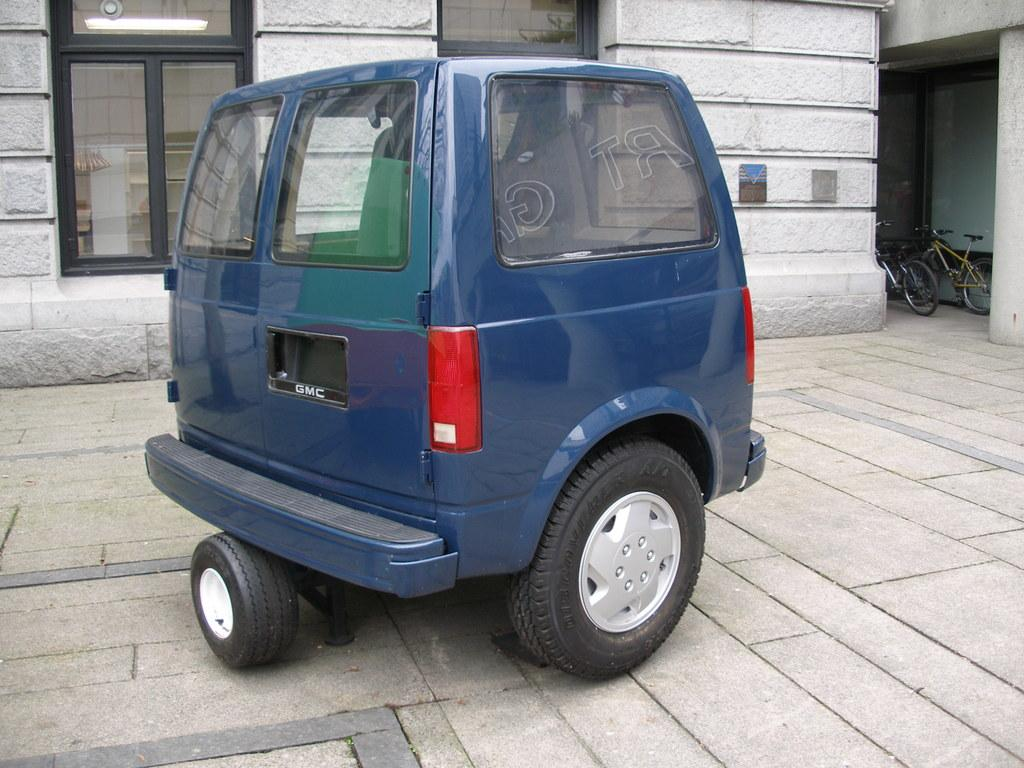What is the main subject in the image? There is a vehicle in the image. Can you describe the position of the vehicle? The vehicle is on a surface. What else can be seen in the image besides the vehicle? There is a building with windows in the image, and two bicycles parked aside. How is the building positioned in relation to the vehicle? The building is located behind the vehicle. What type of map can be seen on the wall inside the building? There is no map visible in the image; it only shows the vehicle, building, and bicycles from the outside. 